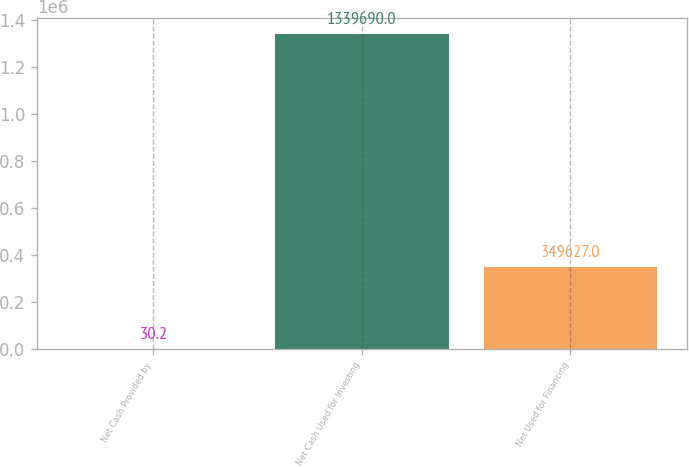<chart> <loc_0><loc_0><loc_500><loc_500><bar_chart><fcel>Net Cash Provided by<fcel>Net Cash Used for Investing<fcel>Net Used for Financing<nl><fcel>30.2<fcel>1.33969e+06<fcel>349627<nl></chart> 